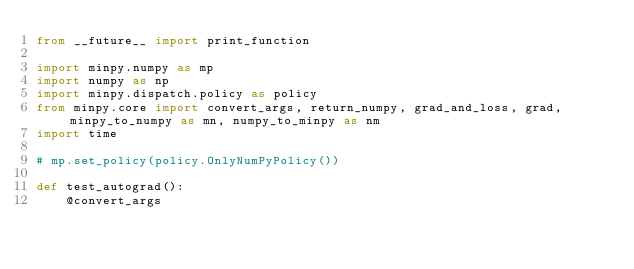Convert code to text. <code><loc_0><loc_0><loc_500><loc_500><_Python_>from __future__ import print_function

import minpy.numpy as mp
import numpy as np
import minpy.dispatch.policy as policy
from minpy.core import convert_args, return_numpy, grad_and_loss, grad, minpy_to_numpy as mn, numpy_to_minpy as nm
import time

# mp.set_policy(policy.OnlyNumPyPolicy())

def test_autograd():
    @convert_args</code> 